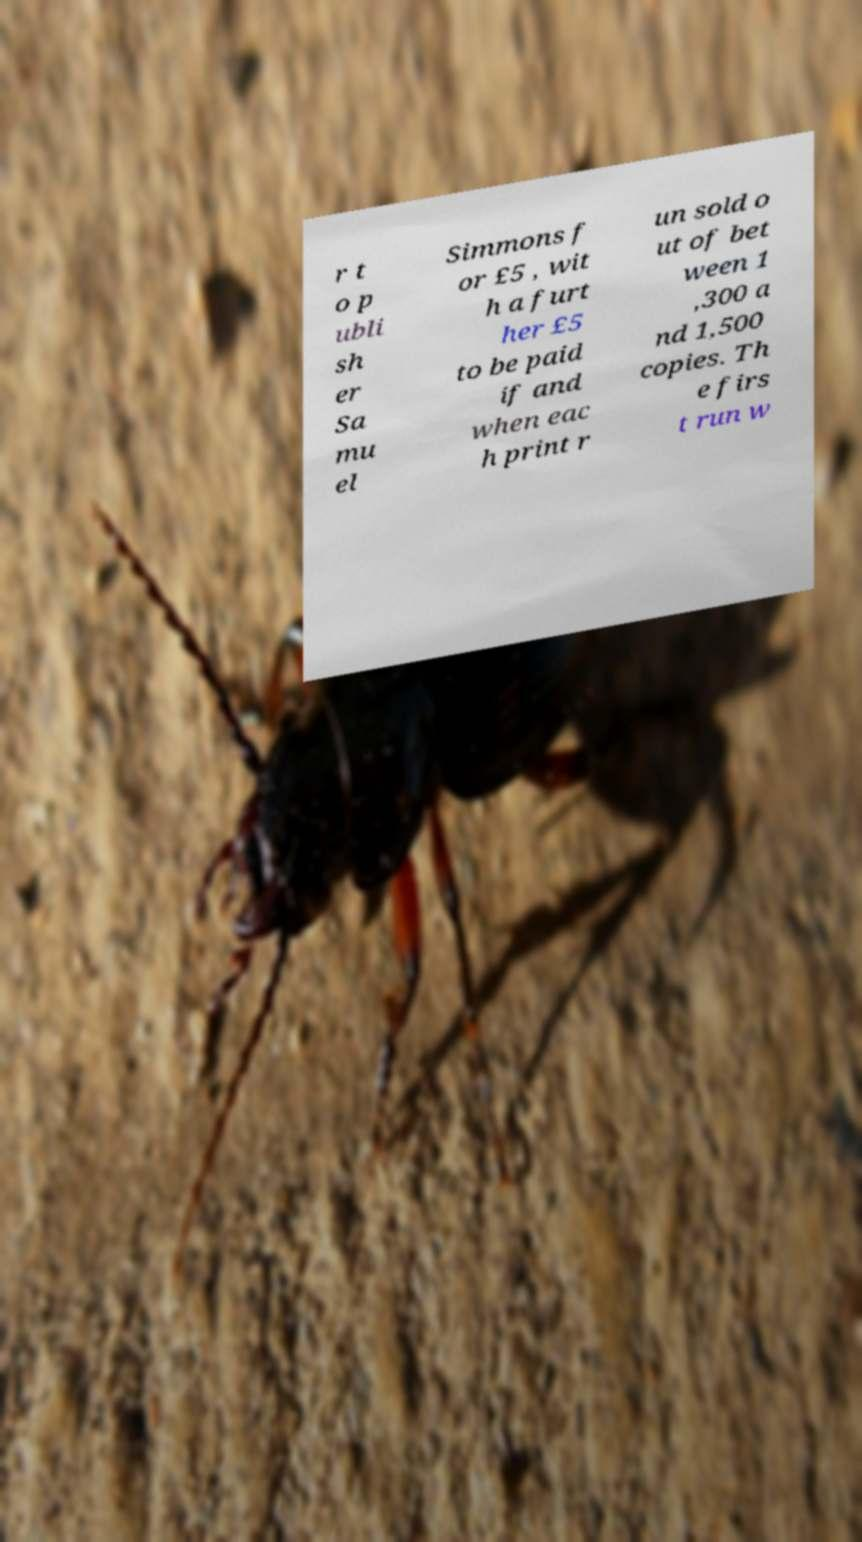Could you extract and type out the text from this image? r t o p ubli sh er Sa mu el Simmons f or £5 , wit h a furt her £5 to be paid if and when eac h print r un sold o ut of bet ween 1 ,300 a nd 1,500 copies. Th e firs t run w 